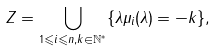Convert formula to latex. <formula><loc_0><loc_0><loc_500><loc_500>Z = \bigcup _ { 1 \leqslant i \leqslant n , k \in \mathbb { N } ^ { * } } \{ \lambda \mu _ { i } ( \lambda ) = - k \} ,</formula> 